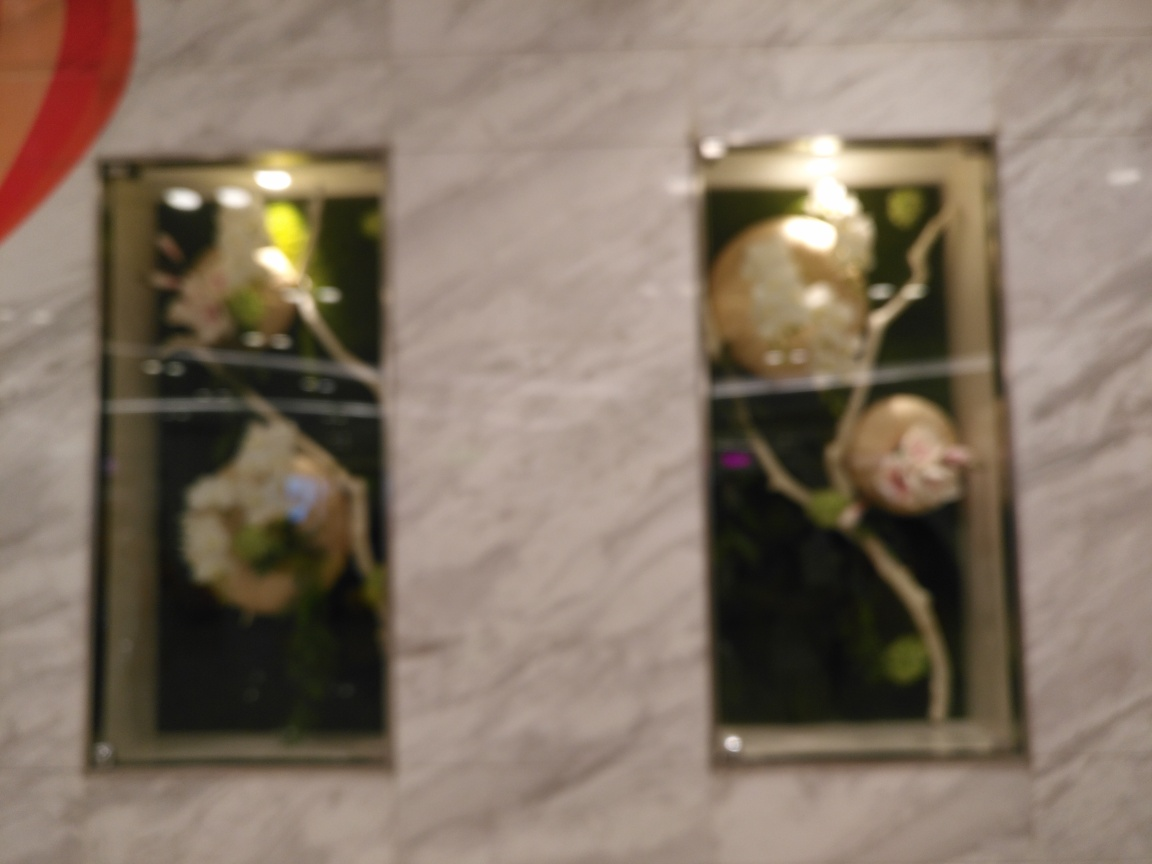What improvements could be made to capture a clearer image of the subject matter in this photograph? To capture a clearer image, one might ensure that the camera is stable, perhaps by using a tripod or steadying it on a flat surface. Additionally, adjusting the focus settings manually could help, along with using a narrower aperture to increase the depth of field, which could bring more of the scene into focus. Ensuring the camera's autofocus is targeting the desired part of the scene would also be essential. 